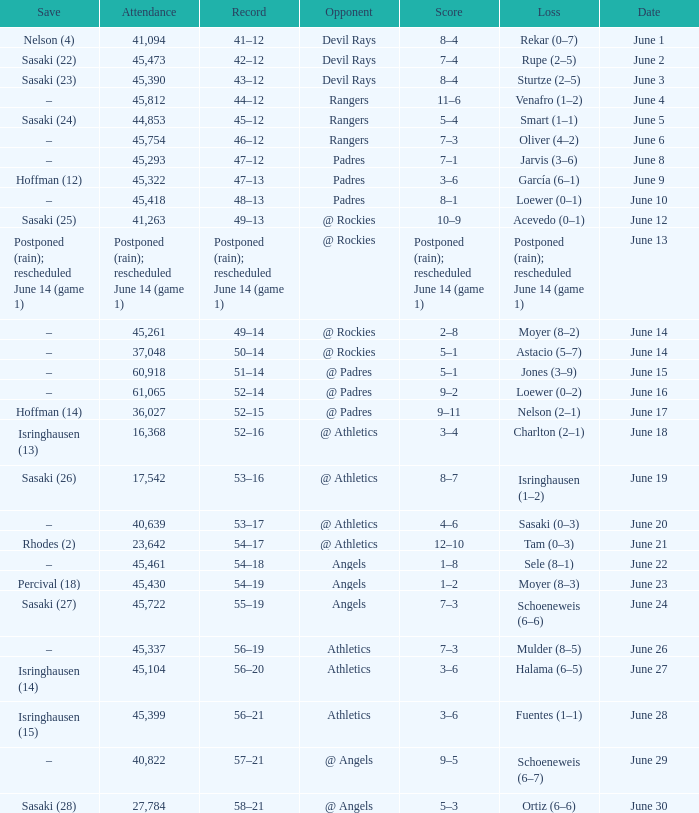What was the attendance of the Mariners game when they had a record of 56–20? 45104.0. 